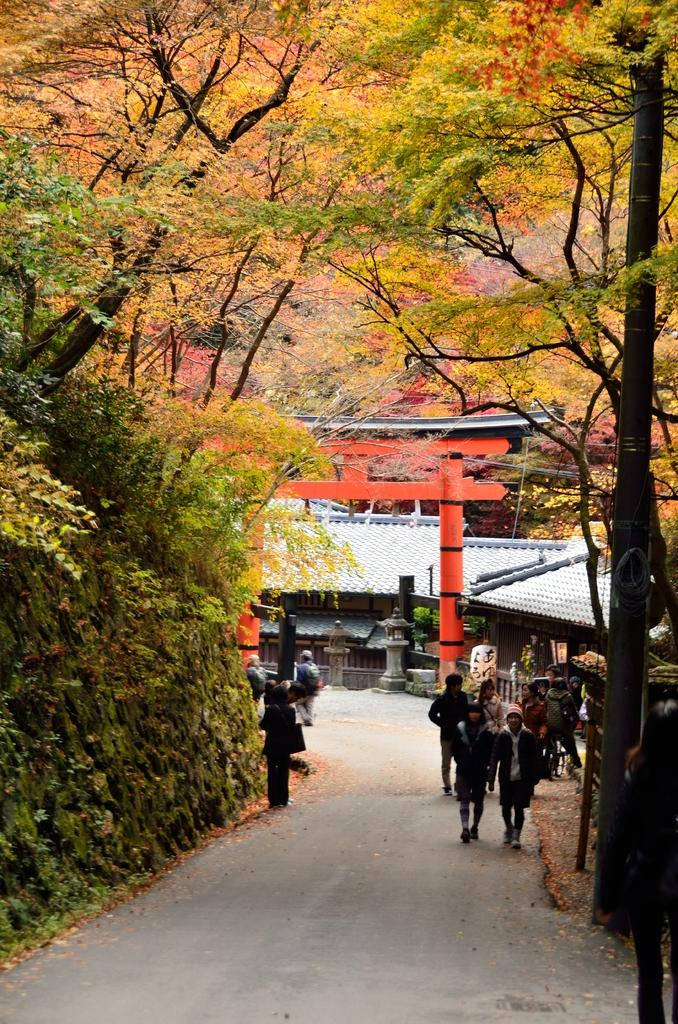What type of natural elements can be seen in the image? There are trees in the image. What type of man-made structures are visible in the image? There are buildings in the image. What are the people in the image doing? People are walking on the road in the image. What type of vertical structures can be seen in the image? There are poles visible in the image. What other objects can be seen beside the road in the image? There are other objects beside the road in the image. What is the cause of the protest happening in the image? There is no protest present in the image; it features trees, buildings, people walking on the road, poles, and other objects beside the road. How much dust can be seen in the image? There is no mention of dust in the image, so it cannot be determined from the provided facts. 